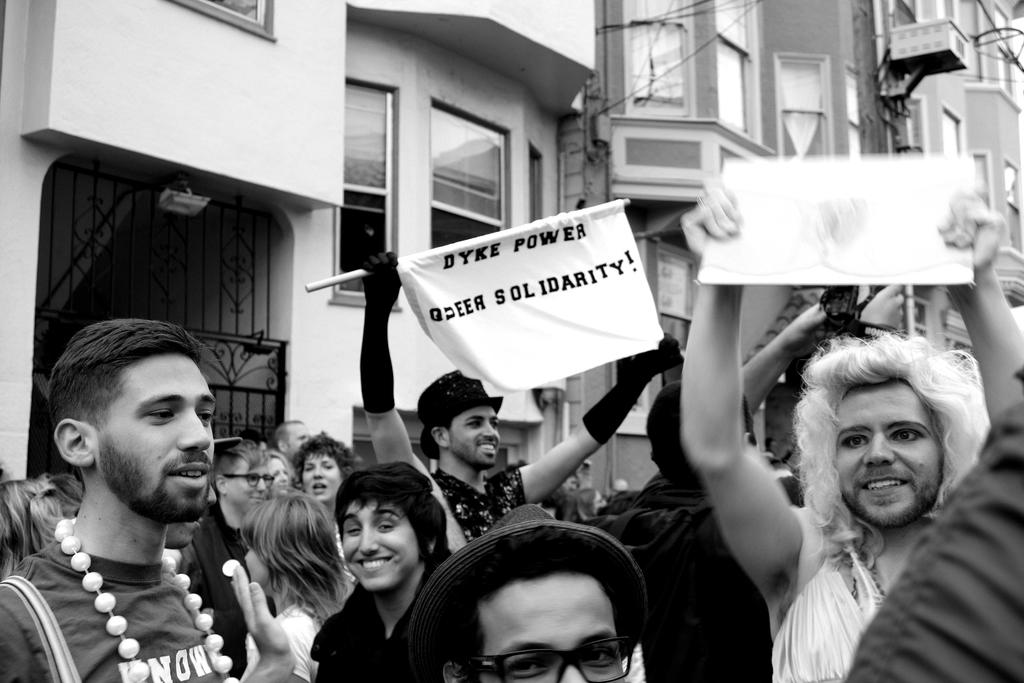What is the color scheme of the image? The image is black and white. What can be seen on the left side of the image? There are buildings on the left side of the image. What architectural feature is visible in the image? There are windows visible in the image. What type of entrance is present in the image? There is a gate in the image. What are some people doing in the image? Some people are holding banners in the image. What type of sugar is being used by the spy in the image? There is no spy or sugar present in the image. What type of work are the people in the image doing? The image does not provide information about the type of work the people are doing; it only shows them holding banners. 